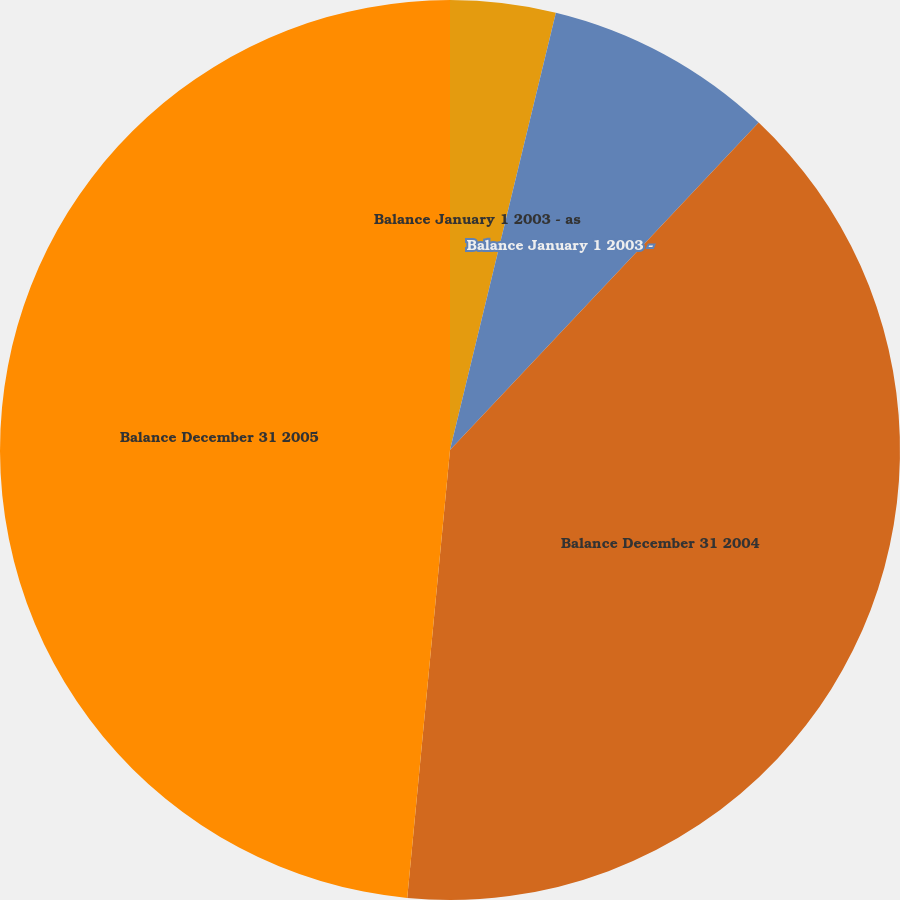<chart> <loc_0><loc_0><loc_500><loc_500><pie_chart><fcel>Balance January 1 2003 - as<fcel>Balance January 1 2003 -<fcel>Balance December 31 2004<fcel>Balance December 31 2005<nl><fcel>3.78%<fcel>8.25%<fcel>39.48%<fcel>48.48%<nl></chart> 